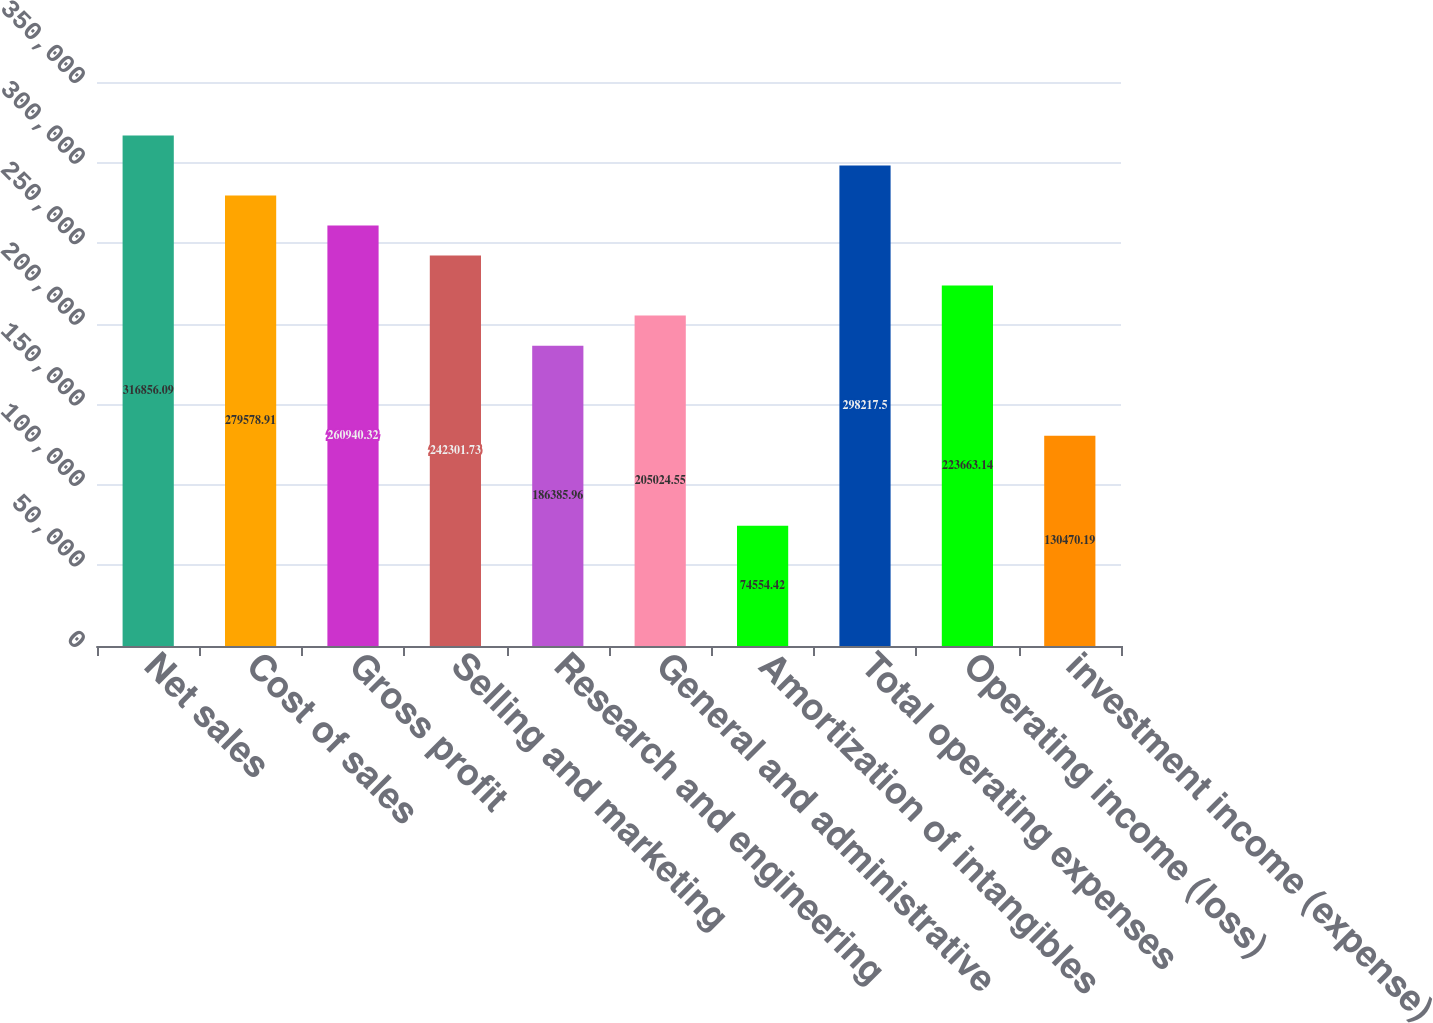Convert chart. <chart><loc_0><loc_0><loc_500><loc_500><bar_chart><fcel>Net sales<fcel>Cost of sales<fcel>Gross profit<fcel>Selling and marketing<fcel>Research and engineering<fcel>General and administrative<fcel>Amortization of intangibles<fcel>Total operating expenses<fcel>Operating income (loss)<fcel>investment income (expense)<nl><fcel>316856<fcel>279579<fcel>260940<fcel>242302<fcel>186386<fcel>205025<fcel>74554.4<fcel>298218<fcel>223663<fcel>130470<nl></chart> 